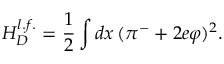Convert formula to latex. <formula><loc_0><loc_0><loc_500><loc_500>H _ { D } ^ { l . f . } = \frac { 1 } { 2 } \int d x \, ( \pi ^ { - } + 2 e \varphi ) ^ { 2 } .</formula> 